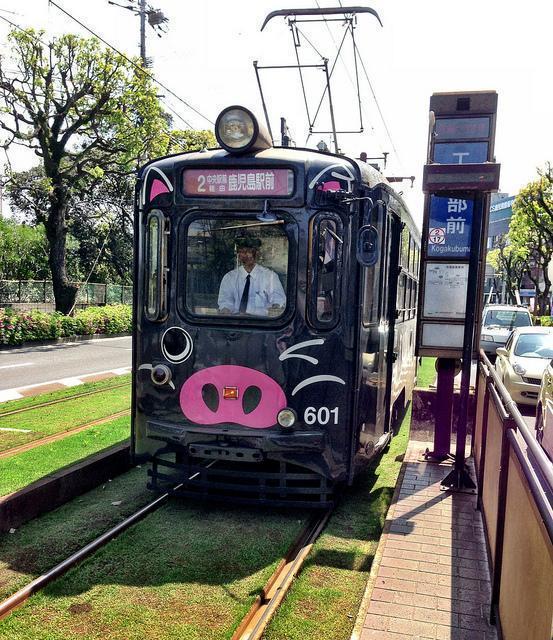How is the trolley powered?
From the following four choices, select the correct answer to address the question.
Options: Solar, gas, nuclear, electricity. Electricity. 